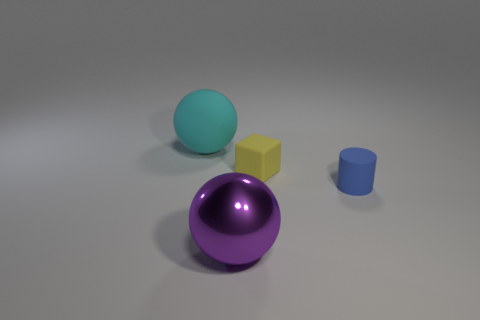There is a thing that is behind the yellow cube; is its color the same as the matte cylinder that is behind the large purple metal object?
Offer a very short reply. No. How many other objects are the same color as the small block?
Make the answer very short. 0. There is a big shiny object that is on the right side of the big matte thing; what shape is it?
Your answer should be very brief. Sphere. Is the number of brown spheres less than the number of tiny rubber things?
Offer a very short reply. Yes. Does the large ball in front of the small blue cylinder have the same material as the cylinder?
Keep it short and to the point. No. Is there any other thing that has the same size as the yellow block?
Provide a short and direct response. Yes. Are there any purple metallic balls left of the big cyan sphere?
Your answer should be very brief. No. The big sphere that is in front of the cyan rubber thing that is to the left of the large sphere that is in front of the matte block is what color?
Offer a very short reply. Purple. There is a blue rubber object that is the same size as the block; what shape is it?
Provide a succinct answer. Cylinder. Is the number of large cyan things greater than the number of small shiny blocks?
Your answer should be very brief. Yes. 